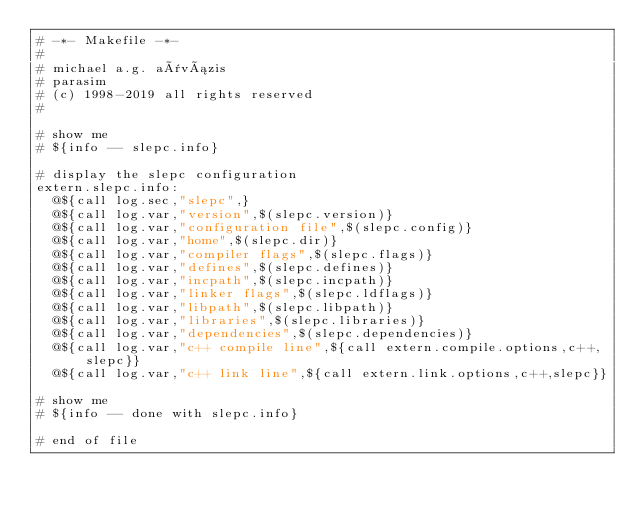Convert code to text. <code><loc_0><loc_0><loc_500><loc_500><_ObjectiveC_># -*- Makefile -*-
#
# michael a.g. aïvázis
# parasim
# (c) 1998-2019 all rights reserved
#

# show me
# ${info -- slepc.info}

# display the slepc configuration
extern.slepc.info:
	@${call log.sec,"slepc",}
	@${call log.var,"version",$(slepc.version)}
	@${call log.var,"configuration file",$(slepc.config)}
	@${call log.var,"home",$(slepc.dir)}
	@${call log.var,"compiler flags",$(slepc.flags)}
	@${call log.var,"defines",$(slepc.defines)}
	@${call log.var,"incpath",$(slepc.incpath)}
	@${call log.var,"linker flags",$(slepc.ldflags)}
	@${call log.var,"libpath",$(slepc.libpath)}
	@${call log.var,"libraries",$(slepc.libraries)}
	@${call log.var,"dependencies",$(slepc.dependencies)}
	@${call log.var,"c++ compile line",${call extern.compile.options,c++,slepc}}
	@${call log.var,"c++ link line",${call extern.link.options,c++,slepc}}

# show me
# ${info -- done with slepc.info}

# end of file
</code> 